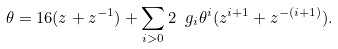<formula> <loc_0><loc_0><loc_500><loc_500>\theta = 1 6 ( z + z ^ { - 1 } ) + \sum _ { i > 0 } 2 \ g _ { i } \theta ^ { i } ( z ^ { i + 1 } + z ^ { - ( i + 1 ) } ) .</formula> 